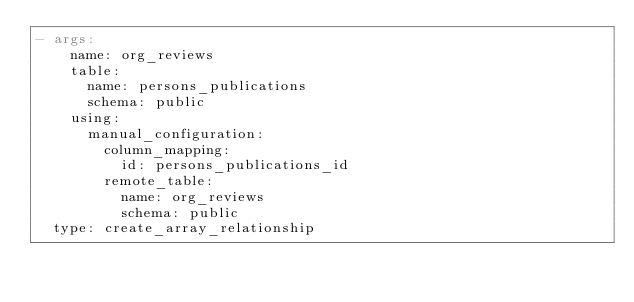<code> <loc_0><loc_0><loc_500><loc_500><_YAML_>- args:
    name: org_reviews
    table:
      name: persons_publications
      schema: public
    using:
      manual_configuration:
        column_mapping:
          id: persons_publications_id
        remote_table:
          name: org_reviews
          schema: public
  type: create_array_relationship
</code> 